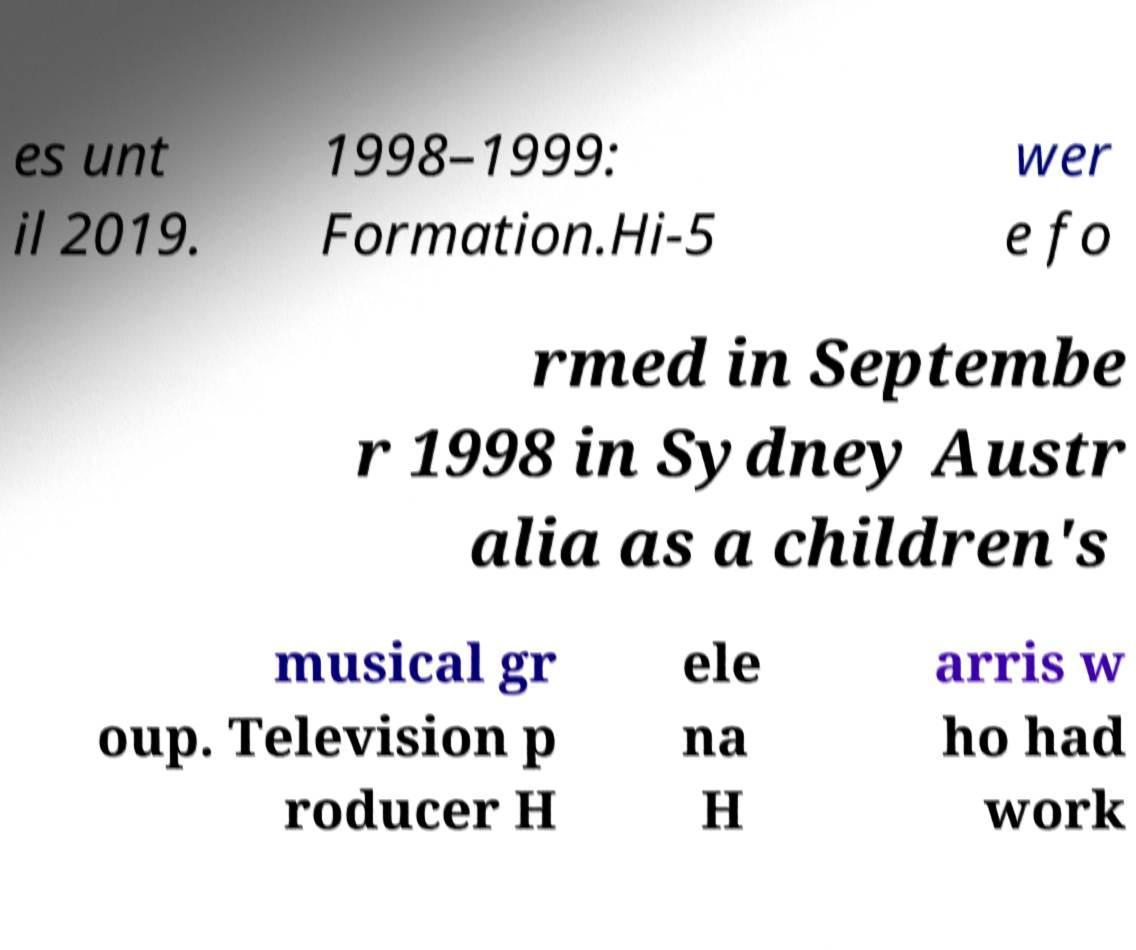Please read and relay the text visible in this image. What does it say? es unt il 2019. 1998–1999: Formation.Hi-5 wer e fo rmed in Septembe r 1998 in Sydney Austr alia as a children's musical gr oup. Television p roducer H ele na H arris w ho had work 